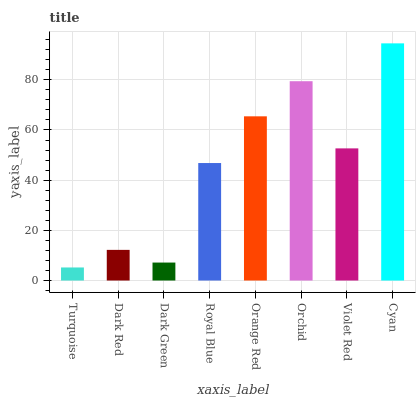Is Turquoise the minimum?
Answer yes or no. Yes. Is Cyan the maximum?
Answer yes or no. Yes. Is Dark Red the minimum?
Answer yes or no. No. Is Dark Red the maximum?
Answer yes or no. No. Is Dark Red greater than Turquoise?
Answer yes or no. Yes. Is Turquoise less than Dark Red?
Answer yes or no. Yes. Is Turquoise greater than Dark Red?
Answer yes or no. No. Is Dark Red less than Turquoise?
Answer yes or no. No. Is Violet Red the high median?
Answer yes or no. Yes. Is Royal Blue the low median?
Answer yes or no. Yes. Is Dark Red the high median?
Answer yes or no. No. Is Turquoise the low median?
Answer yes or no. No. 